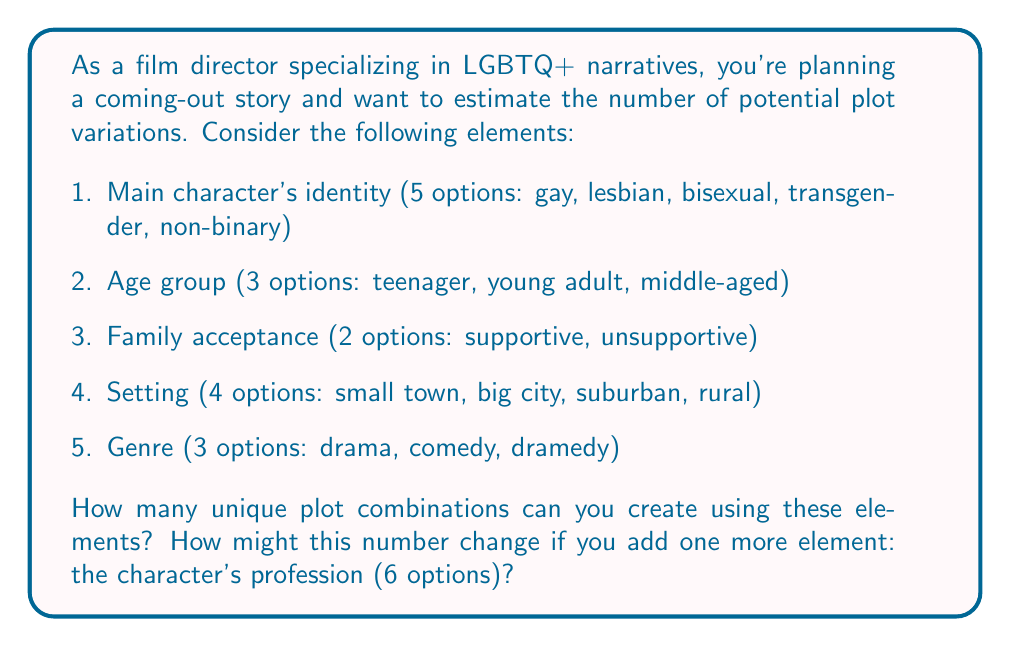Can you answer this question? To solve this problem, we'll use the multiplication principle of counting. This principle states that if we have $n$ independent events, and each event $i$ has $m_i$ possible outcomes, then the total number of possible outcomes for all events is the product of the number of outcomes for each event.

1. For the initial set of elements:
   - Main character's identity: 5 options
   - Age group: 3 options
   - Family acceptance: 2 options
   - Setting: 4 options
   - Genre: 3 options

   Total combinations = $5 \times 3 \times 2 \times 4 \times 3 = 360$

2. Adding the character's profession (6 options):
   New total combinations = $360 \times 6 = 2160$

The addition of one more element with 6 options increases the number of combinations by a factor of 6.

This calculation demonstrates how quickly the number of potential plot variations can grow with the addition of new elements, offering a wide range of storytelling possibilities for LGBTQ+ narratives.
Answer: Initial number of unique plot combinations: 360
Number of unique plot combinations after adding character's profession: 2160 